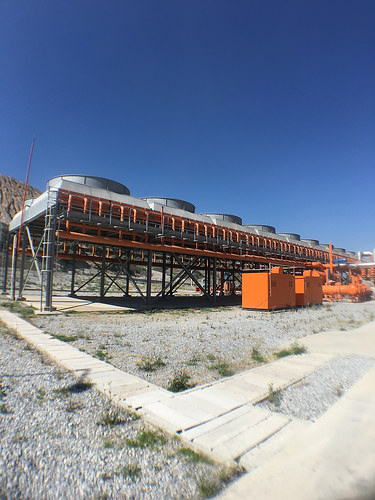<image>
Is the box to the right of the railing? Yes. From this viewpoint, the box is positioned to the right side relative to the railing. 